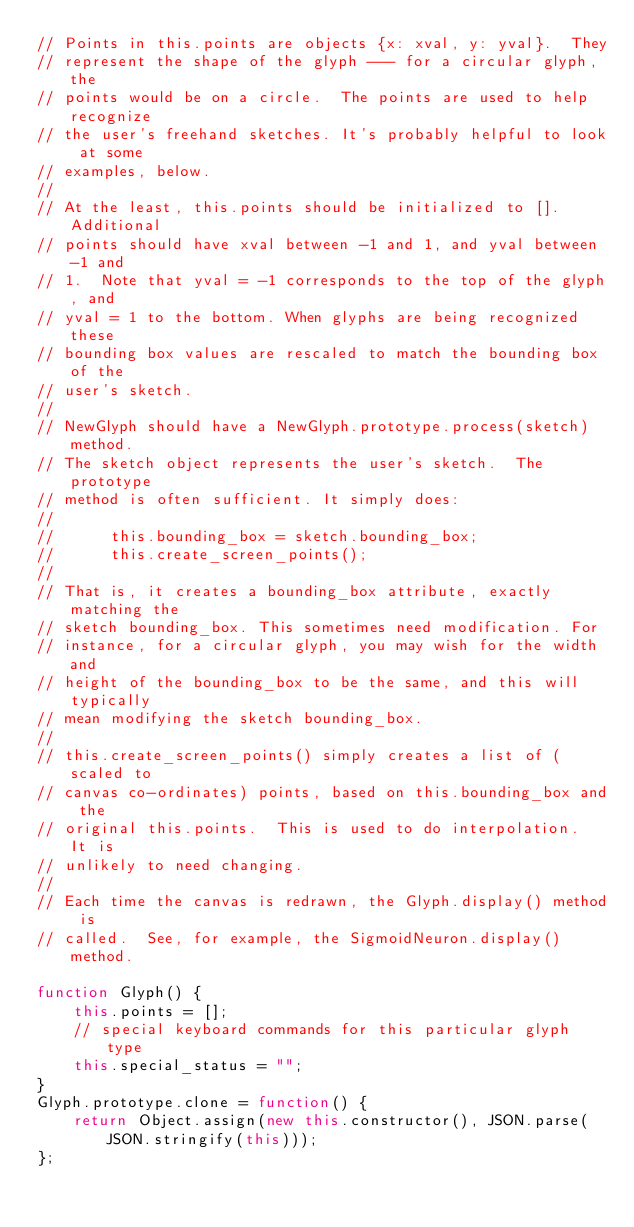Convert code to text. <code><loc_0><loc_0><loc_500><loc_500><_JavaScript_>// Points in this.points are objects {x: xval, y: yval}.  They
// represent the shape of the glyph --- for a circular glyph, the
// points would be on a circle.  The points are used to help recognize
// the user's freehand sketches. It's probably helpful to look at some
// examples, below.
//
// At the least, this.points should be initialized to [].  Additional
// points should have xval between -1 and 1, and yval between -1 and
// 1.  Note that yval = -1 corresponds to the top of the glyph, and
// yval = 1 to the bottom. When glyphs are being recognized these
// bounding box values are rescaled to match the bounding box of the
// user's sketch.
//
// NewGlyph should have a NewGlyph.prototype.process(sketch) method.
// The sketch object represents the user's sketch.  The prototype
// method is often sufficient. It simply does:
//
//      this.bounding_box = sketch.bounding_box;
//      this.create_screen_points();
//
// That is, it creates a bounding_box attribute, exactly matching the
// sketch bounding_box. This sometimes need modification. For
// instance, for a circular glyph, you may wish for the width and
// height of the bounding_box to be the same, and this will typically
// mean modifying the sketch bounding_box.
//
// this.create_screen_points() simply creates a list of (scaled to
// canvas co-ordinates) points, based on this.bounding_box and the
// original this.points.  This is used to do interpolation.  It is
// unlikely to need changing.
//
// Each time the canvas is redrawn, the Glyph.display() method is
// called.  See, for example, the SigmoidNeuron.display() method.

function Glyph() {
    this.points = [];
    // special keyboard commands for this particular glyph type
    this.special_status = "";
}
Glyph.prototype.clone = function() {
    return Object.assign(new this.constructor(), JSON.parse(JSON.stringify(this)));
};</code> 